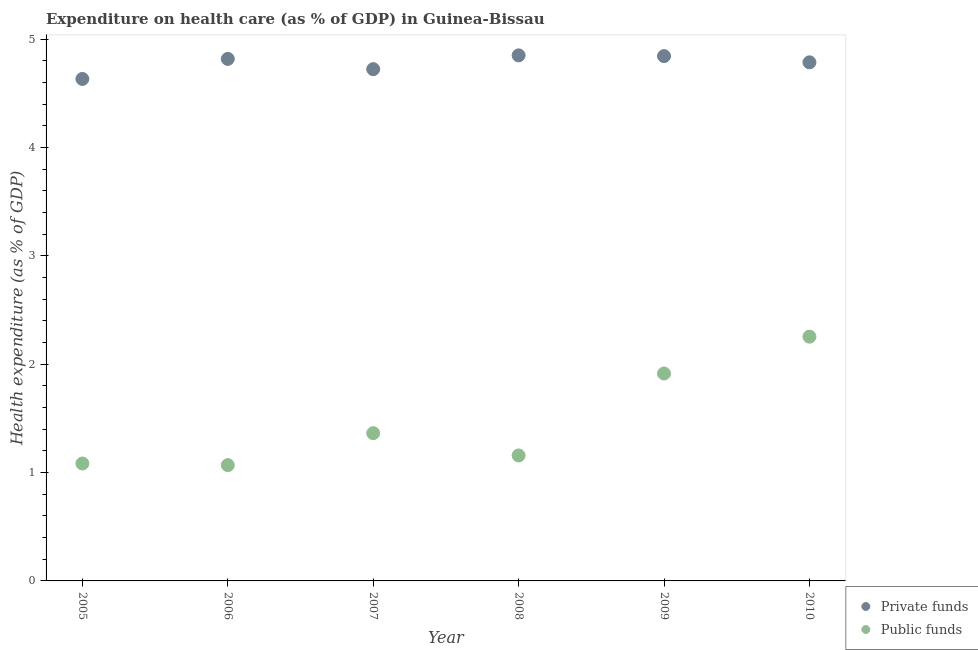How many different coloured dotlines are there?
Your answer should be very brief. 2. What is the amount of public funds spent in healthcare in 2008?
Give a very brief answer. 1.16. Across all years, what is the maximum amount of private funds spent in healthcare?
Provide a succinct answer. 4.85. Across all years, what is the minimum amount of private funds spent in healthcare?
Provide a succinct answer. 4.63. In which year was the amount of private funds spent in healthcare maximum?
Keep it short and to the point. 2008. In which year was the amount of private funds spent in healthcare minimum?
Your answer should be compact. 2005. What is the total amount of private funds spent in healthcare in the graph?
Make the answer very short. 28.65. What is the difference between the amount of private funds spent in healthcare in 2006 and that in 2009?
Your response must be concise. -0.03. What is the difference between the amount of public funds spent in healthcare in 2008 and the amount of private funds spent in healthcare in 2005?
Provide a short and direct response. -3.47. What is the average amount of public funds spent in healthcare per year?
Your answer should be very brief. 1.47. In the year 2009, what is the difference between the amount of public funds spent in healthcare and amount of private funds spent in healthcare?
Keep it short and to the point. -2.93. What is the ratio of the amount of private funds spent in healthcare in 2005 to that in 2007?
Keep it short and to the point. 0.98. Is the difference between the amount of public funds spent in healthcare in 2005 and 2007 greater than the difference between the amount of private funds spent in healthcare in 2005 and 2007?
Make the answer very short. No. What is the difference between the highest and the second highest amount of public funds spent in healthcare?
Keep it short and to the point. 0.34. What is the difference between the highest and the lowest amount of public funds spent in healthcare?
Your answer should be very brief. 1.19. In how many years, is the amount of private funds spent in healthcare greater than the average amount of private funds spent in healthcare taken over all years?
Offer a very short reply. 4. Is the sum of the amount of public funds spent in healthcare in 2009 and 2010 greater than the maximum amount of private funds spent in healthcare across all years?
Your response must be concise. No. How many dotlines are there?
Your answer should be compact. 2. How many years are there in the graph?
Keep it short and to the point. 6. Are the values on the major ticks of Y-axis written in scientific E-notation?
Your answer should be very brief. No. Does the graph contain any zero values?
Give a very brief answer. No. Does the graph contain grids?
Provide a succinct answer. No. Where does the legend appear in the graph?
Provide a succinct answer. Bottom right. How many legend labels are there?
Give a very brief answer. 2. What is the title of the graph?
Give a very brief answer. Expenditure on health care (as % of GDP) in Guinea-Bissau. What is the label or title of the X-axis?
Offer a terse response. Year. What is the label or title of the Y-axis?
Offer a very short reply. Health expenditure (as % of GDP). What is the Health expenditure (as % of GDP) of Private funds in 2005?
Your answer should be very brief. 4.63. What is the Health expenditure (as % of GDP) in Public funds in 2005?
Offer a terse response. 1.08. What is the Health expenditure (as % of GDP) of Private funds in 2006?
Your answer should be compact. 4.82. What is the Health expenditure (as % of GDP) in Public funds in 2006?
Ensure brevity in your answer.  1.07. What is the Health expenditure (as % of GDP) of Private funds in 2007?
Keep it short and to the point. 4.72. What is the Health expenditure (as % of GDP) in Public funds in 2007?
Offer a terse response. 1.36. What is the Health expenditure (as % of GDP) in Private funds in 2008?
Provide a succinct answer. 4.85. What is the Health expenditure (as % of GDP) of Public funds in 2008?
Offer a very short reply. 1.16. What is the Health expenditure (as % of GDP) in Private funds in 2009?
Give a very brief answer. 4.84. What is the Health expenditure (as % of GDP) in Public funds in 2009?
Your answer should be compact. 1.91. What is the Health expenditure (as % of GDP) of Private funds in 2010?
Your response must be concise. 4.79. What is the Health expenditure (as % of GDP) in Public funds in 2010?
Provide a short and direct response. 2.25. Across all years, what is the maximum Health expenditure (as % of GDP) of Private funds?
Keep it short and to the point. 4.85. Across all years, what is the maximum Health expenditure (as % of GDP) in Public funds?
Your answer should be compact. 2.25. Across all years, what is the minimum Health expenditure (as % of GDP) in Private funds?
Offer a terse response. 4.63. Across all years, what is the minimum Health expenditure (as % of GDP) of Public funds?
Your answer should be very brief. 1.07. What is the total Health expenditure (as % of GDP) of Private funds in the graph?
Offer a very short reply. 28.65. What is the total Health expenditure (as % of GDP) in Public funds in the graph?
Your answer should be compact. 8.84. What is the difference between the Health expenditure (as % of GDP) of Private funds in 2005 and that in 2006?
Give a very brief answer. -0.18. What is the difference between the Health expenditure (as % of GDP) in Public funds in 2005 and that in 2006?
Make the answer very short. 0.01. What is the difference between the Health expenditure (as % of GDP) in Private funds in 2005 and that in 2007?
Your answer should be compact. -0.09. What is the difference between the Health expenditure (as % of GDP) in Public funds in 2005 and that in 2007?
Provide a short and direct response. -0.28. What is the difference between the Health expenditure (as % of GDP) of Private funds in 2005 and that in 2008?
Give a very brief answer. -0.22. What is the difference between the Health expenditure (as % of GDP) in Public funds in 2005 and that in 2008?
Make the answer very short. -0.07. What is the difference between the Health expenditure (as % of GDP) of Private funds in 2005 and that in 2009?
Offer a very short reply. -0.21. What is the difference between the Health expenditure (as % of GDP) of Public funds in 2005 and that in 2009?
Provide a short and direct response. -0.83. What is the difference between the Health expenditure (as % of GDP) of Private funds in 2005 and that in 2010?
Ensure brevity in your answer.  -0.15. What is the difference between the Health expenditure (as % of GDP) in Public funds in 2005 and that in 2010?
Provide a short and direct response. -1.17. What is the difference between the Health expenditure (as % of GDP) in Private funds in 2006 and that in 2007?
Your answer should be very brief. 0.09. What is the difference between the Health expenditure (as % of GDP) in Public funds in 2006 and that in 2007?
Provide a succinct answer. -0.29. What is the difference between the Health expenditure (as % of GDP) in Private funds in 2006 and that in 2008?
Give a very brief answer. -0.03. What is the difference between the Health expenditure (as % of GDP) of Public funds in 2006 and that in 2008?
Make the answer very short. -0.09. What is the difference between the Health expenditure (as % of GDP) in Private funds in 2006 and that in 2009?
Your answer should be very brief. -0.03. What is the difference between the Health expenditure (as % of GDP) of Public funds in 2006 and that in 2009?
Ensure brevity in your answer.  -0.85. What is the difference between the Health expenditure (as % of GDP) in Private funds in 2006 and that in 2010?
Ensure brevity in your answer.  0.03. What is the difference between the Health expenditure (as % of GDP) of Public funds in 2006 and that in 2010?
Offer a terse response. -1.19. What is the difference between the Health expenditure (as % of GDP) in Private funds in 2007 and that in 2008?
Make the answer very short. -0.13. What is the difference between the Health expenditure (as % of GDP) of Public funds in 2007 and that in 2008?
Make the answer very short. 0.21. What is the difference between the Health expenditure (as % of GDP) in Private funds in 2007 and that in 2009?
Your answer should be very brief. -0.12. What is the difference between the Health expenditure (as % of GDP) of Public funds in 2007 and that in 2009?
Make the answer very short. -0.55. What is the difference between the Health expenditure (as % of GDP) in Private funds in 2007 and that in 2010?
Keep it short and to the point. -0.06. What is the difference between the Health expenditure (as % of GDP) of Public funds in 2007 and that in 2010?
Your answer should be very brief. -0.89. What is the difference between the Health expenditure (as % of GDP) of Private funds in 2008 and that in 2009?
Offer a terse response. 0.01. What is the difference between the Health expenditure (as % of GDP) of Public funds in 2008 and that in 2009?
Your response must be concise. -0.76. What is the difference between the Health expenditure (as % of GDP) of Private funds in 2008 and that in 2010?
Keep it short and to the point. 0.06. What is the difference between the Health expenditure (as % of GDP) of Public funds in 2008 and that in 2010?
Provide a succinct answer. -1.1. What is the difference between the Health expenditure (as % of GDP) in Private funds in 2009 and that in 2010?
Give a very brief answer. 0.06. What is the difference between the Health expenditure (as % of GDP) in Public funds in 2009 and that in 2010?
Keep it short and to the point. -0.34. What is the difference between the Health expenditure (as % of GDP) of Private funds in 2005 and the Health expenditure (as % of GDP) of Public funds in 2006?
Give a very brief answer. 3.56. What is the difference between the Health expenditure (as % of GDP) in Private funds in 2005 and the Health expenditure (as % of GDP) in Public funds in 2007?
Provide a succinct answer. 3.27. What is the difference between the Health expenditure (as % of GDP) in Private funds in 2005 and the Health expenditure (as % of GDP) in Public funds in 2008?
Your answer should be compact. 3.47. What is the difference between the Health expenditure (as % of GDP) in Private funds in 2005 and the Health expenditure (as % of GDP) in Public funds in 2009?
Offer a very short reply. 2.72. What is the difference between the Health expenditure (as % of GDP) of Private funds in 2005 and the Health expenditure (as % of GDP) of Public funds in 2010?
Make the answer very short. 2.38. What is the difference between the Health expenditure (as % of GDP) of Private funds in 2006 and the Health expenditure (as % of GDP) of Public funds in 2007?
Your response must be concise. 3.45. What is the difference between the Health expenditure (as % of GDP) in Private funds in 2006 and the Health expenditure (as % of GDP) in Public funds in 2008?
Provide a succinct answer. 3.66. What is the difference between the Health expenditure (as % of GDP) of Private funds in 2006 and the Health expenditure (as % of GDP) of Public funds in 2009?
Ensure brevity in your answer.  2.9. What is the difference between the Health expenditure (as % of GDP) in Private funds in 2006 and the Health expenditure (as % of GDP) in Public funds in 2010?
Make the answer very short. 2.56. What is the difference between the Health expenditure (as % of GDP) in Private funds in 2007 and the Health expenditure (as % of GDP) in Public funds in 2008?
Your response must be concise. 3.56. What is the difference between the Health expenditure (as % of GDP) of Private funds in 2007 and the Health expenditure (as % of GDP) of Public funds in 2009?
Your response must be concise. 2.81. What is the difference between the Health expenditure (as % of GDP) in Private funds in 2007 and the Health expenditure (as % of GDP) in Public funds in 2010?
Keep it short and to the point. 2.47. What is the difference between the Health expenditure (as % of GDP) of Private funds in 2008 and the Health expenditure (as % of GDP) of Public funds in 2009?
Provide a short and direct response. 2.94. What is the difference between the Health expenditure (as % of GDP) in Private funds in 2008 and the Health expenditure (as % of GDP) in Public funds in 2010?
Your answer should be compact. 2.6. What is the difference between the Health expenditure (as % of GDP) in Private funds in 2009 and the Health expenditure (as % of GDP) in Public funds in 2010?
Offer a terse response. 2.59. What is the average Health expenditure (as % of GDP) of Private funds per year?
Make the answer very short. 4.77. What is the average Health expenditure (as % of GDP) in Public funds per year?
Offer a terse response. 1.47. In the year 2005, what is the difference between the Health expenditure (as % of GDP) of Private funds and Health expenditure (as % of GDP) of Public funds?
Keep it short and to the point. 3.55. In the year 2006, what is the difference between the Health expenditure (as % of GDP) in Private funds and Health expenditure (as % of GDP) in Public funds?
Give a very brief answer. 3.75. In the year 2007, what is the difference between the Health expenditure (as % of GDP) of Private funds and Health expenditure (as % of GDP) of Public funds?
Your answer should be very brief. 3.36. In the year 2008, what is the difference between the Health expenditure (as % of GDP) in Private funds and Health expenditure (as % of GDP) in Public funds?
Provide a short and direct response. 3.69. In the year 2009, what is the difference between the Health expenditure (as % of GDP) in Private funds and Health expenditure (as % of GDP) in Public funds?
Ensure brevity in your answer.  2.93. In the year 2010, what is the difference between the Health expenditure (as % of GDP) of Private funds and Health expenditure (as % of GDP) of Public funds?
Provide a short and direct response. 2.53. What is the ratio of the Health expenditure (as % of GDP) of Private funds in 2005 to that in 2006?
Give a very brief answer. 0.96. What is the ratio of the Health expenditure (as % of GDP) in Private funds in 2005 to that in 2007?
Provide a succinct answer. 0.98. What is the ratio of the Health expenditure (as % of GDP) of Public funds in 2005 to that in 2007?
Ensure brevity in your answer.  0.79. What is the ratio of the Health expenditure (as % of GDP) of Private funds in 2005 to that in 2008?
Your answer should be very brief. 0.96. What is the ratio of the Health expenditure (as % of GDP) of Public funds in 2005 to that in 2008?
Provide a short and direct response. 0.94. What is the ratio of the Health expenditure (as % of GDP) of Private funds in 2005 to that in 2009?
Your answer should be very brief. 0.96. What is the ratio of the Health expenditure (as % of GDP) of Public funds in 2005 to that in 2009?
Give a very brief answer. 0.57. What is the ratio of the Health expenditure (as % of GDP) in Public funds in 2005 to that in 2010?
Make the answer very short. 0.48. What is the ratio of the Health expenditure (as % of GDP) of Private funds in 2006 to that in 2007?
Your response must be concise. 1.02. What is the ratio of the Health expenditure (as % of GDP) in Public funds in 2006 to that in 2007?
Your answer should be very brief. 0.78. What is the ratio of the Health expenditure (as % of GDP) of Public funds in 2006 to that in 2008?
Your answer should be very brief. 0.92. What is the ratio of the Health expenditure (as % of GDP) of Private funds in 2006 to that in 2009?
Give a very brief answer. 0.99. What is the ratio of the Health expenditure (as % of GDP) in Public funds in 2006 to that in 2009?
Provide a succinct answer. 0.56. What is the ratio of the Health expenditure (as % of GDP) in Private funds in 2006 to that in 2010?
Your response must be concise. 1.01. What is the ratio of the Health expenditure (as % of GDP) in Public funds in 2006 to that in 2010?
Give a very brief answer. 0.47. What is the ratio of the Health expenditure (as % of GDP) in Private funds in 2007 to that in 2008?
Give a very brief answer. 0.97. What is the ratio of the Health expenditure (as % of GDP) in Public funds in 2007 to that in 2008?
Provide a succinct answer. 1.18. What is the ratio of the Health expenditure (as % of GDP) in Private funds in 2007 to that in 2009?
Keep it short and to the point. 0.98. What is the ratio of the Health expenditure (as % of GDP) of Public funds in 2007 to that in 2009?
Ensure brevity in your answer.  0.71. What is the ratio of the Health expenditure (as % of GDP) in Private funds in 2007 to that in 2010?
Ensure brevity in your answer.  0.99. What is the ratio of the Health expenditure (as % of GDP) of Public funds in 2007 to that in 2010?
Make the answer very short. 0.6. What is the ratio of the Health expenditure (as % of GDP) of Public funds in 2008 to that in 2009?
Your response must be concise. 0.6. What is the ratio of the Health expenditure (as % of GDP) in Private funds in 2008 to that in 2010?
Offer a terse response. 1.01. What is the ratio of the Health expenditure (as % of GDP) in Public funds in 2008 to that in 2010?
Your answer should be very brief. 0.51. What is the ratio of the Health expenditure (as % of GDP) in Private funds in 2009 to that in 2010?
Offer a terse response. 1.01. What is the ratio of the Health expenditure (as % of GDP) of Public funds in 2009 to that in 2010?
Offer a terse response. 0.85. What is the difference between the highest and the second highest Health expenditure (as % of GDP) of Private funds?
Offer a very short reply. 0.01. What is the difference between the highest and the second highest Health expenditure (as % of GDP) in Public funds?
Give a very brief answer. 0.34. What is the difference between the highest and the lowest Health expenditure (as % of GDP) in Private funds?
Your response must be concise. 0.22. What is the difference between the highest and the lowest Health expenditure (as % of GDP) of Public funds?
Make the answer very short. 1.19. 